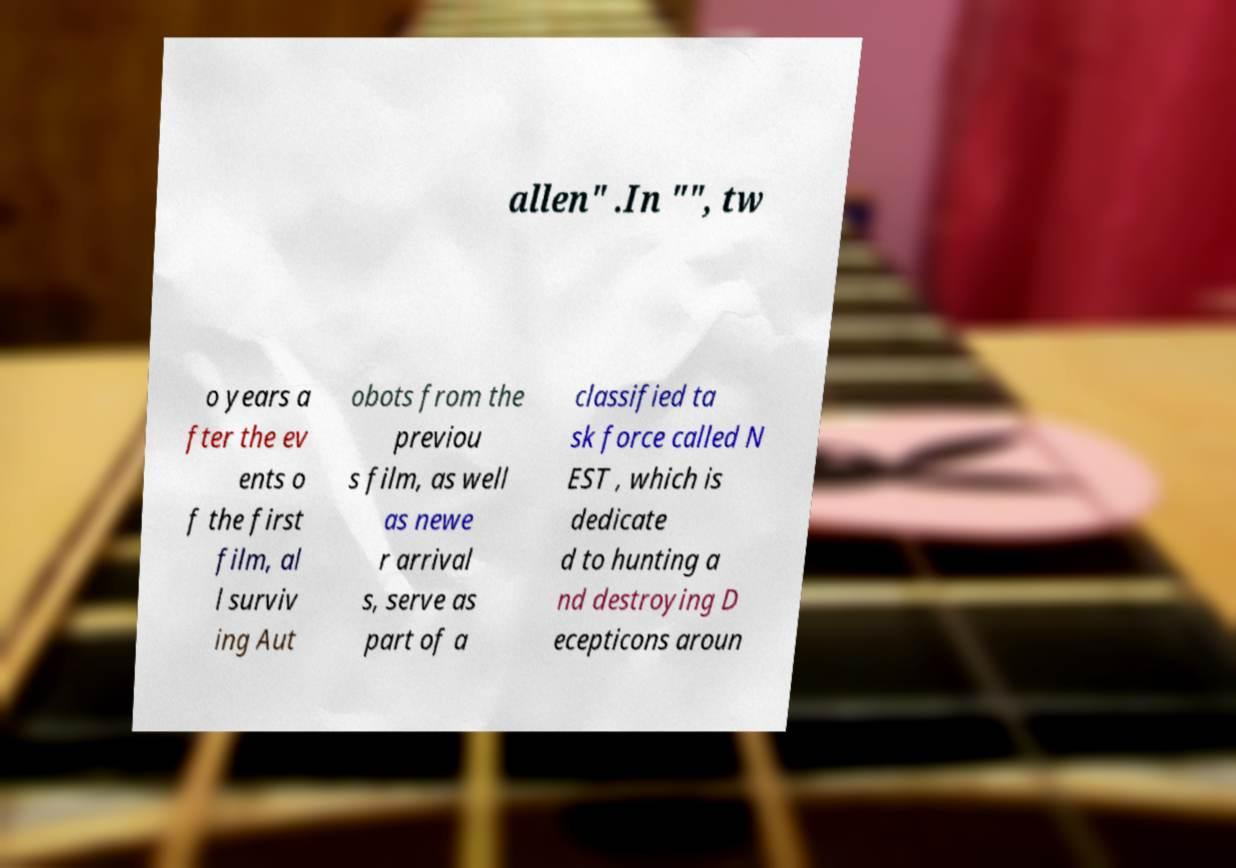Could you assist in decoding the text presented in this image and type it out clearly? allen" .In "", tw o years a fter the ev ents o f the first film, al l surviv ing Aut obots from the previou s film, as well as newe r arrival s, serve as part of a classified ta sk force called N EST , which is dedicate d to hunting a nd destroying D ecepticons aroun 